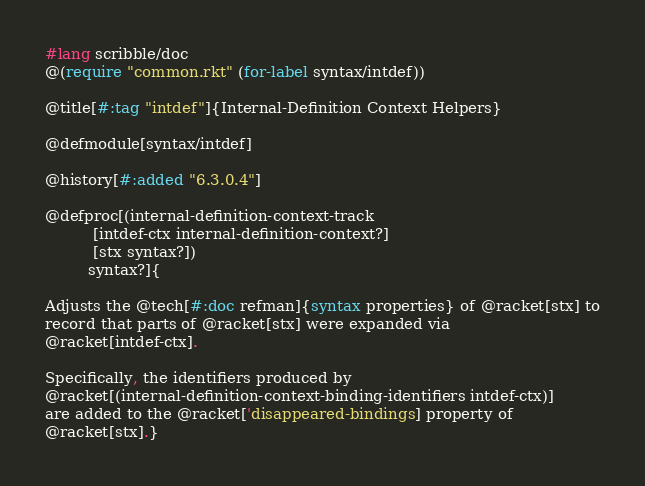Convert code to text. <code><loc_0><loc_0><loc_500><loc_500><_Racket_>#lang scribble/doc
@(require "common.rkt" (for-label syntax/intdef))

@title[#:tag "intdef"]{Internal-Definition Context Helpers}

@defmodule[syntax/intdef]

@history[#:added "6.3.0.4"]

@defproc[(internal-definition-context-track
          [intdef-ctx internal-definition-context?]
          [stx syntax?])
         syntax?]{

Adjusts the @tech[#:doc refman]{syntax properties} of @racket[stx] to
record that parts of @racket[stx] were expanded via
@racket[intdef-ctx].

Specifically, the identifiers produced by
@racket[(internal-definition-context-binding-identifiers intdef-ctx)]
are added to the @racket['disappeared-bindings] property of
@racket[stx].}
</code> 